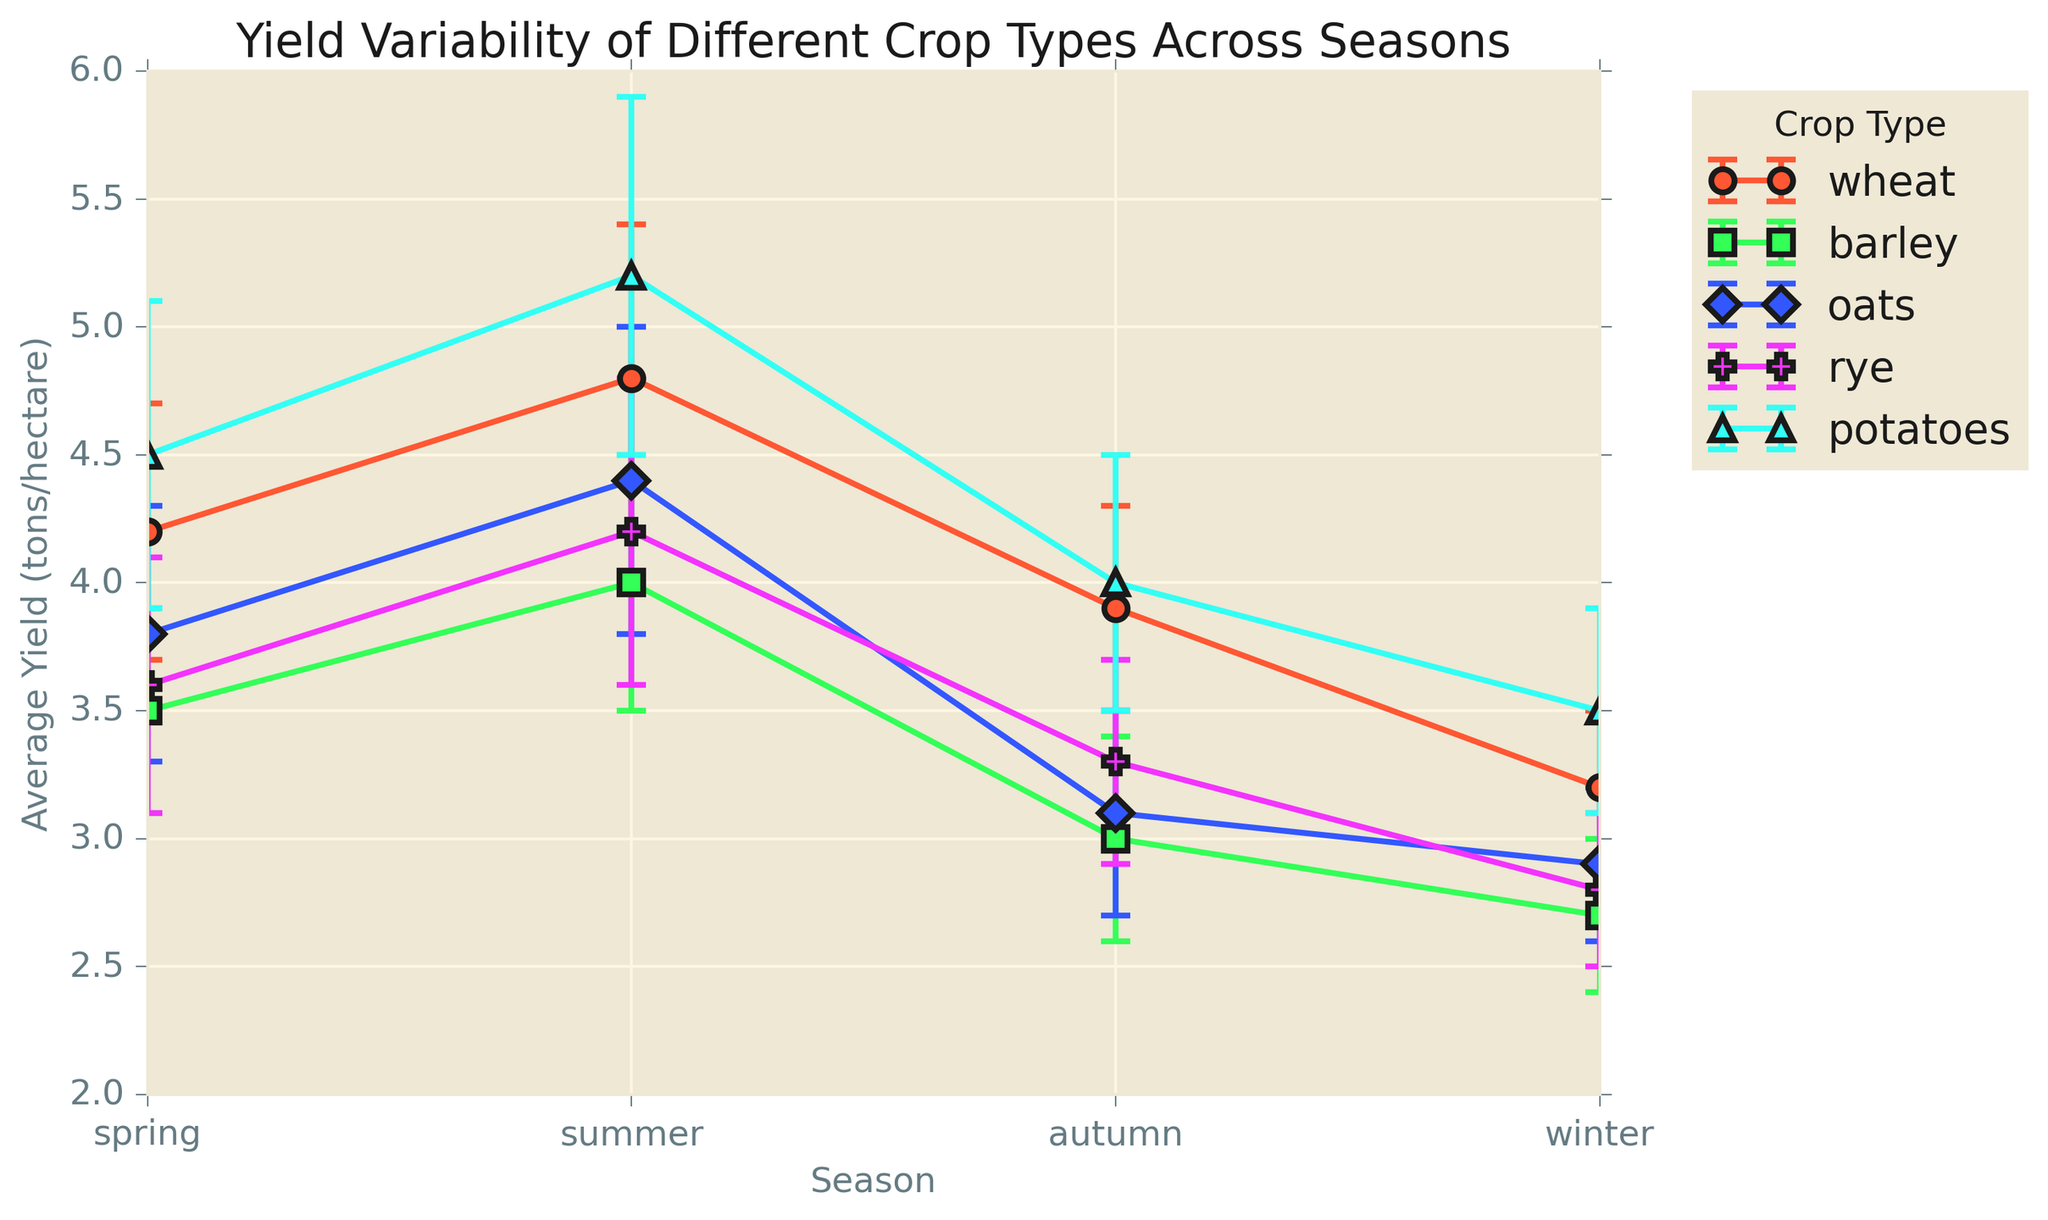Which crop type has the highest yield in summer? To find the crop with the highest yield in summer, look at the summer yield values for all crop types and identify the maximum. Potatoes have the highest yield in summer at 5.2 tons/hectare.
Answer: Potatoes Which season has the least yield for rye? Check the yield values for rye across all seasons and identify the season with the lowest yield. Winter has the lowest yield for rye at 2.8 tons/hectare.
Answer: Winter What is the difference in yield between wheat in summer and autumn? To find the difference in yield between wheat in summer and autumn, subtract the autumn yield of wheat from the summer yield. The yield in summer for wheat is 4.8 and in autumn, it is 3.9. The difference is 4.8 - 3.9 = 0.9 tons/hectare.
Answer: 0.9 tons/hectare Which crop type shows the most variability in yields across the seasons? Variability is represented by the length of the error bars. Find the crop with the longest average error bars across all seasons. Potatoes show the most variability with larger error bars compared to other crops.
Answer: Potatoes What is the average yield of oats in spring and summer? To find the average yield of oats in these seasons, add the yield in spring and summer, then divide by 2. The yield in spring for oats is 3.8, and in summer, it is 4.4. So, (3.8 + 4.4) / 2 = 4.1 tons/hectare.
Answer: 4.1 tons/hectare Which crop type's yield is least affected by seasonal changes? Yields least affected by seasonal changes will have the smallest range between the highest and lowest yields. Calculate the range for each crop and identify the smallest range. For barley, the range is from 2.7 to 4.0, which is 1.3, showing the least variation.
Answer: Barley Compare the yield of barley and oats in winter. Which is higher? Compare the yield values of barley and oats in winter. Barley yields 2.7 tons/hectare and oats yield 2.9 tons/hectare. Oats have a higher yield.
Answer: Oats What is the combined yield of potatoes in spring and autumn? To find the combined yield, add the yield values for potatoes in spring and autumn. The spring yield is 4.5 and the autumn yield is 4.0. Therefore, 4.5 + 4.0 = 8.5 tons/hectare.
Answer: 8.5 tons/hectare Is the yield of rye in spring higher or lower than wheat in autumn? Compare the yield of rye in spring with the yield of wheat in autumn. Rye has a yield of 3.6 in spring, and wheat has a yield of 3.9 in autumn. Rye's yield is lower.
Answer: Lower How much does the average yield of barley in summer exceed the average yield of barley in autumn? Subtract the yield of barley in autumn from that in summer. The yield in summer for barley is 4.0 and in autumn, it is 3.0. Therefore, 4.0 - 3.0 = 1.0 ton/hectare.
Answer: 1.0 ton/hectare 